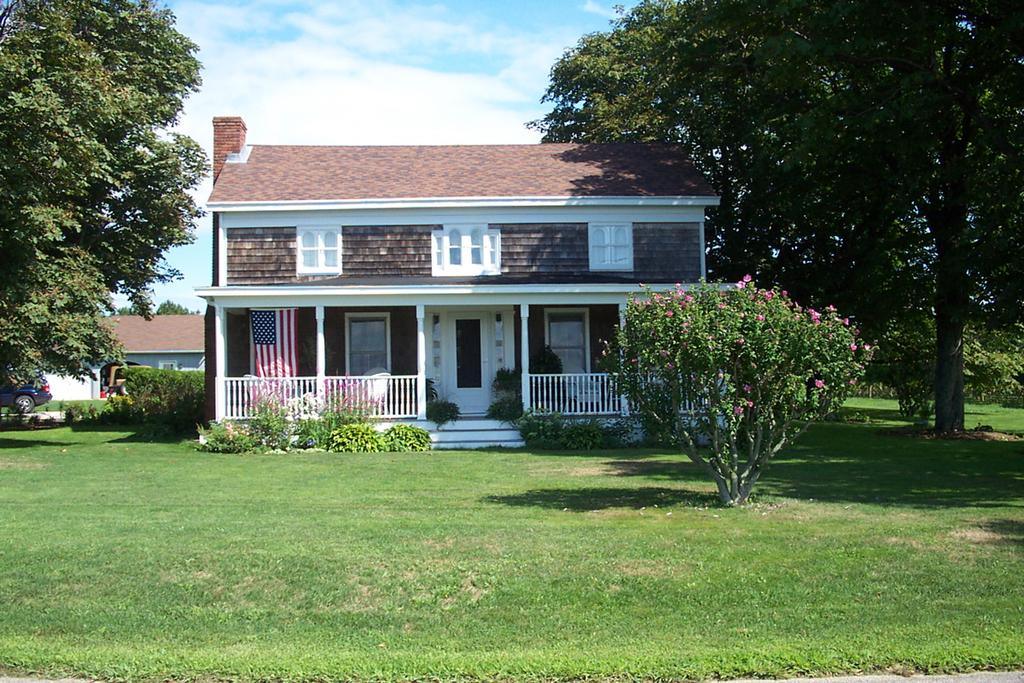What is the main setting of the image? The main setting of the image is an open grass ground. What can be observed on the grass ground? Shadows are visible on the grass ground in the image. What type of vegetation is present in the image? There are plants and trees in the image. What man-made structures can be seen in the image? There are buildings in the image. What is the symbolic object in the image? There is a flag in the image. What can be seen in the background of the image? Clouds and the sky are visible in the background of the image. What type of toe is visible on the grass ground in the image? There are no toes visible in the image; it features an open grass ground with various elements but no body parts. What is the name of the downtown area depicted in the image? The image does not show a downtown area; it features an open grass ground with various elements but no urban setting. 